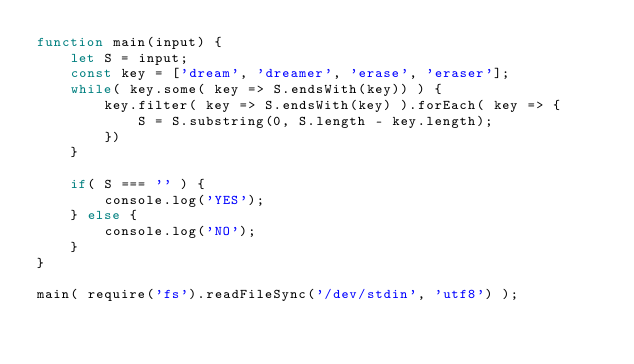Convert code to text. <code><loc_0><loc_0><loc_500><loc_500><_JavaScript_>function main(input) {
    let S = input;
    const key = ['dream', 'dreamer', 'erase', 'eraser'];
    while( key.some( key => S.endsWith(key)) ) {
        key.filter( key => S.endsWith(key) ).forEach( key => {
            S = S.substring(0, S.length - key.length);
        })
    }

    if( S === '' ) {
        console.log('YES');
    } else {
        console.log('NO');
    }
}

main( require('fs').readFileSync('/dev/stdin', 'utf8') );</code> 